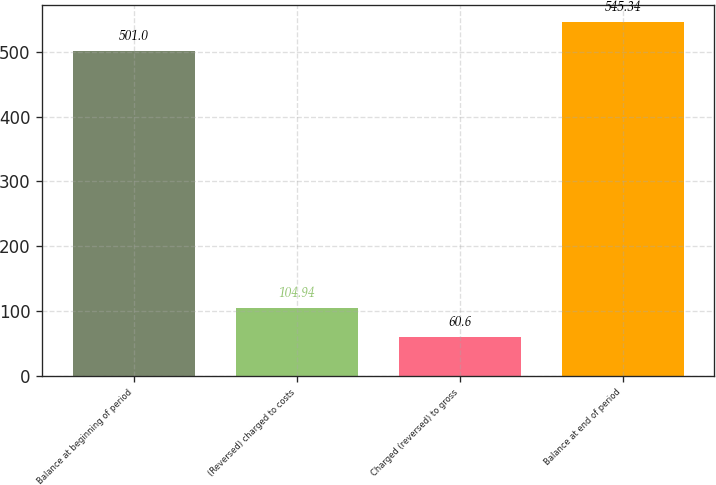Convert chart to OTSL. <chart><loc_0><loc_0><loc_500><loc_500><bar_chart><fcel>Balance at beginning of period<fcel>(Reversed) charged to costs<fcel>Charged (reversed) to gross<fcel>Balance at end of period<nl><fcel>501<fcel>104.94<fcel>60.6<fcel>545.34<nl></chart> 